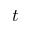Convert formula to latex. <formula><loc_0><loc_0><loc_500><loc_500>t</formula> 